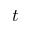Convert formula to latex. <formula><loc_0><loc_0><loc_500><loc_500>t</formula> 